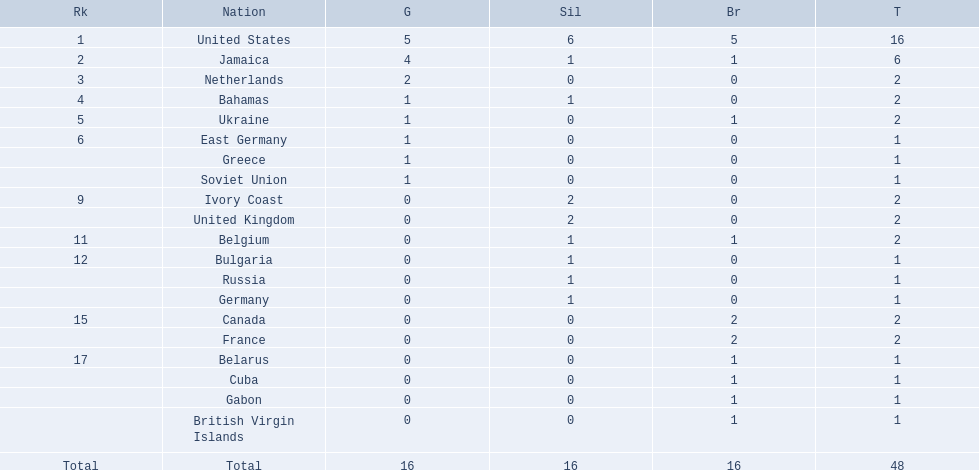Which countries participated? United States, Jamaica, Netherlands, Bahamas, Ukraine, East Germany, Greece, Soviet Union, Ivory Coast, United Kingdom, Belgium, Bulgaria, Russia, Germany, Canada, France, Belarus, Cuba, Gabon, British Virgin Islands. How many gold medals were won by each? 5, 4, 2, 1, 1, 1, 1, 1, 0, 0, 0, 0, 0, 0, 0, 0, 0, 0, 0, 0. And which country won the most? United States. 